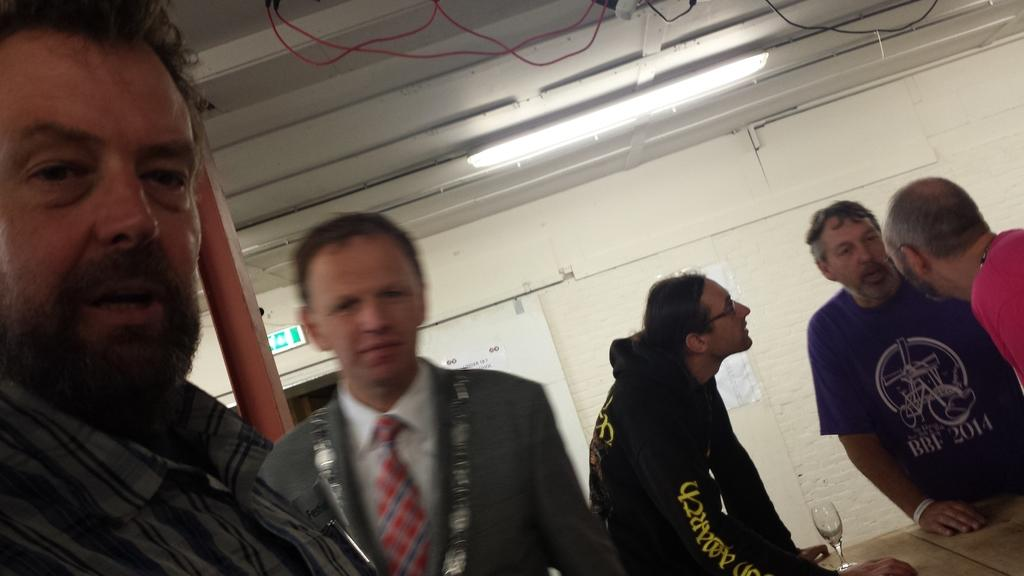What type of decoration is present on the walls in the image? There is wallpaper in the image. Can you describe the lighting in the image? There is a light source in the image. Who or what is present in the image? There is a group of people in the image. What piece of furniture can be seen in the image? There is a table in the image. What object is on the table in the image? There is a glass on the table. What type of stomach pain is the group of people experiencing in the image? There is no indication of any stomach pain or discomfort in the image; the focus is on the wallpaper, light source, group of people, table, and glass. What part of the table is the glass placed on in the image? The glass is placed on the table in the image, but there is no specific part of the table mentioned in the facts provided. 